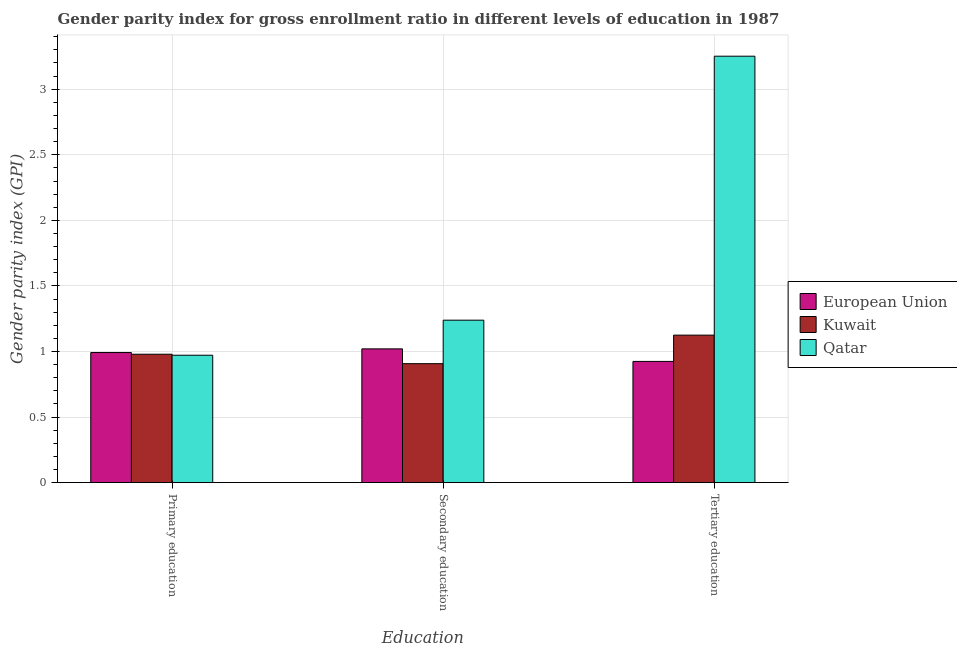Are the number of bars per tick equal to the number of legend labels?
Offer a terse response. Yes. Are the number of bars on each tick of the X-axis equal?
Your answer should be very brief. Yes. What is the label of the 1st group of bars from the left?
Your answer should be very brief. Primary education. What is the gender parity index in secondary education in Kuwait?
Your answer should be very brief. 0.91. Across all countries, what is the maximum gender parity index in tertiary education?
Provide a succinct answer. 3.25. Across all countries, what is the minimum gender parity index in primary education?
Provide a short and direct response. 0.97. In which country was the gender parity index in secondary education maximum?
Make the answer very short. Qatar. What is the total gender parity index in secondary education in the graph?
Keep it short and to the point. 3.17. What is the difference between the gender parity index in primary education in Qatar and that in Kuwait?
Offer a very short reply. -0.01. What is the difference between the gender parity index in tertiary education in Qatar and the gender parity index in primary education in Kuwait?
Keep it short and to the point. 2.27. What is the average gender parity index in tertiary education per country?
Provide a succinct answer. 1.77. What is the difference between the gender parity index in primary education and gender parity index in tertiary education in European Union?
Your answer should be very brief. 0.07. What is the ratio of the gender parity index in primary education in Qatar to that in Kuwait?
Provide a succinct answer. 0.99. Is the gender parity index in primary education in Qatar less than that in European Union?
Provide a short and direct response. Yes. What is the difference between the highest and the second highest gender parity index in tertiary education?
Keep it short and to the point. 2.13. What is the difference between the highest and the lowest gender parity index in secondary education?
Your answer should be very brief. 0.33. In how many countries, is the gender parity index in tertiary education greater than the average gender parity index in tertiary education taken over all countries?
Provide a short and direct response. 1. What does the 3rd bar from the left in Primary education represents?
Your answer should be very brief. Qatar. What does the 2nd bar from the right in Tertiary education represents?
Provide a succinct answer. Kuwait. Is it the case that in every country, the sum of the gender parity index in primary education and gender parity index in secondary education is greater than the gender parity index in tertiary education?
Make the answer very short. No. How many bars are there?
Your answer should be very brief. 9. How many countries are there in the graph?
Give a very brief answer. 3. Are the values on the major ticks of Y-axis written in scientific E-notation?
Offer a terse response. No. Does the graph contain grids?
Your response must be concise. Yes. Where does the legend appear in the graph?
Give a very brief answer. Center right. What is the title of the graph?
Your answer should be compact. Gender parity index for gross enrollment ratio in different levels of education in 1987. Does "Israel" appear as one of the legend labels in the graph?
Provide a short and direct response. No. What is the label or title of the X-axis?
Give a very brief answer. Education. What is the label or title of the Y-axis?
Your response must be concise. Gender parity index (GPI). What is the Gender parity index (GPI) in European Union in Primary education?
Make the answer very short. 0.99. What is the Gender parity index (GPI) in Kuwait in Primary education?
Give a very brief answer. 0.98. What is the Gender parity index (GPI) in Qatar in Primary education?
Offer a very short reply. 0.97. What is the Gender parity index (GPI) of European Union in Secondary education?
Offer a terse response. 1.02. What is the Gender parity index (GPI) of Kuwait in Secondary education?
Give a very brief answer. 0.91. What is the Gender parity index (GPI) of Qatar in Secondary education?
Give a very brief answer. 1.24. What is the Gender parity index (GPI) of European Union in Tertiary education?
Provide a short and direct response. 0.92. What is the Gender parity index (GPI) of Kuwait in Tertiary education?
Your response must be concise. 1.12. What is the Gender parity index (GPI) of Qatar in Tertiary education?
Your answer should be compact. 3.25. Across all Education, what is the maximum Gender parity index (GPI) of European Union?
Your answer should be compact. 1.02. Across all Education, what is the maximum Gender parity index (GPI) of Kuwait?
Offer a very short reply. 1.12. Across all Education, what is the maximum Gender parity index (GPI) of Qatar?
Ensure brevity in your answer.  3.25. Across all Education, what is the minimum Gender parity index (GPI) of European Union?
Your response must be concise. 0.92. Across all Education, what is the minimum Gender parity index (GPI) of Kuwait?
Your answer should be compact. 0.91. Across all Education, what is the minimum Gender parity index (GPI) in Qatar?
Your answer should be very brief. 0.97. What is the total Gender parity index (GPI) of European Union in the graph?
Give a very brief answer. 2.94. What is the total Gender parity index (GPI) of Kuwait in the graph?
Provide a succinct answer. 3.01. What is the total Gender parity index (GPI) in Qatar in the graph?
Make the answer very short. 5.46. What is the difference between the Gender parity index (GPI) in European Union in Primary education and that in Secondary education?
Your response must be concise. -0.03. What is the difference between the Gender parity index (GPI) in Kuwait in Primary education and that in Secondary education?
Offer a very short reply. 0.07. What is the difference between the Gender parity index (GPI) of Qatar in Primary education and that in Secondary education?
Offer a terse response. -0.27. What is the difference between the Gender parity index (GPI) of European Union in Primary education and that in Tertiary education?
Your response must be concise. 0.07. What is the difference between the Gender parity index (GPI) of Kuwait in Primary education and that in Tertiary education?
Provide a short and direct response. -0.15. What is the difference between the Gender parity index (GPI) in Qatar in Primary education and that in Tertiary education?
Your response must be concise. -2.28. What is the difference between the Gender parity index (GPI) of European Union in Secondary education and that in Tertiary education?
Make the answer very short. 0.1. What is the difference between the Gender parity index (GPI) of Kuwait in Secondary education and that in Tertiary education?
Give a very brief answer. -0.22. What is the difference between the Gender parity index (GPI) in Qatar in Secondary education and that in Tertiary education?
Keep it short and to the point. -2.01. What is the difference between the Gender parity index (GPI) in European Union in Primary education and the Gender parity index (GPI) in Kuwait in Secondary education?
Provide a short and direct response. 0.08. What is the difference between the Gender parity index (GPI) in European Union in Primary education and the Gender parity index (GPI) in Qatar in Secondary education?
Your answer should be compact. -0.25. What is the difference between the Gender parity index (GPI) in Kuwait in Primary education and the Gender parity index (GPI) in Qatar in Secondary education?
Provide a succinct answer. -0.26. What is the difference between the Gender parity index (GPI) of European Union in Primary education and the Gender parity index (GPI) of Kuwait in Tertiary education?
Offer a very short reply. -0.13. What is the difference between the Gender parity index (GPI) in European Union in Primary education and the Gender parity index (GPI) in Qatar in Tertiary education?
Provide a succinct answer. -2.26. What is the difference between the Gender parity index (GPI) of Kuwait in Primary education and the Gender parity index (GPI) of Qatar in Tertiary education?
Offer a very short reply. -2.27. What is the difference between the Gender parity index (GPI) in European Union in Secondary education and the Gender parity index (GPI) in Kuwait in Tertiary education?
Your response must be concise. -0.1. What is the difference between the Gender parity index (GPI) in European Union in Secondary education and the Gender parity index (GPI) in Qatar in Tertiary education?
Your answer should be very brief. -2.23. What is the difference between the Gender parity index (GPI) in Kuwait in Secondary education and the Gender parity index (GPI) in Qatar in Tertiary education?
Offer a terse response. -2.34. What is the average Gender parity index (GPI) in European Union per Education?
Ensure brevity in your answer.  0.98. What is the average Gender parity index (GPI) in Qatar per Education?
Your answer should be compact. 1.82. What is the difference between the Gender parity index (GPI) of European Union and Gender parity index (GPI) of Kuwait in Primary education?
Provide a short and direct response. 0.01. What is the difference between the Gender parity index (GPI) of European Union and Gender parity index (GPI) of Qatar in Primary education?
Offer a very short reply. 0.02. What is the difference between the Gender parity index (GPI) of Kuwait and Gender parity index (GPI) of Qatar in Primary education?
Your answer should be very brief. 0.01. What is the difference between the Gender parity index (GPI) in European Union and Gender parity index (GPI) in Kuwait in Secondary education?
Your answer should be very brief. 0.11. What is the difference between the Gender parity index (GPI) of European Union and Gender parity index (GPI) of Qatar in Secondary education?
Ensure brevity in your answer.  -0.22. What is the difference between the Gender parity index (GPI) of Kuwait and Gender parity index (GPI) of Qatar in Secondary education?
Keep it short and to the point. -0.33. What is the difference between the Gender parity index (GPI) in European Union and Gender parity index (GPI) in Kuwait in Tertiary education?
Your answer should be compact. -0.2. What is the difference between the Gender parity index (GPI) in European Union and Gender parity index (GPI) in Qatar in Tertiary education?
Your answer should be compact. -2.33. What is the difference between the Gender parity index (GPI) of Kuwait and Gender parity index (GPI) of Qatar in Tertiary education?
Your answer should be very brief. -2.13. What is the ratio of the Gender parity index (GPI) in European Union in Primary education to that in Secondary education?
Offer a very short reply. 0.97. What is the ratio of the Gender parity index (GPI) in Kuwait in Primary education to that in Secondary education?
Offer a very short reply. 1.08. What is the ratio of the Gender parity index (GPI) of Qatar in Primary education to that in Secondary education?
Make the answer very short. 0.78. What is the ratio of the Gender parity index (GPI) of European Union in Primary education to that in Tertiary education?
Make the answer very short. 1.07. What is the ratio of the Gender parity index (GPI) of Kuwait in Primary education to that in Tertiary education?
Your answer should be very brief. 0.87. What is the ratio of the Gender parity index (GPI) of Qatar in Primary education to that in Tertiary education?
Give a very brief answer. 0.3. What is the ratio of the Gender parity index (GPI) in European Union in Secondary education to that in Tertiary education?
Make the answer very short. 1.1. What is the ratio of the Gender parity index (GPI) in Kuwait in Secondary education to that in Tertiary education?
Give a very brief answer. 0.81. What is the ratio of the Gender parity index (GPI) of Qatar in Secondary education to that in Tertiary education?
Your response must be concise. 0.38. What is the difference between the highest and the second highest Gender parity index (GPI) in European Union?
Your answer should be compact. 0.03. What is the difference between the highest and the second highest Gender parity index (GPI) of Kuwait?
Your answer should be very brief. 0.15. What is the difference between the highest and the second highest Gender parity index (GPI) of Qatar?
Provide a short and direct response. 2.01. What is the difference between the highest and the lowest Gender parity index (GPI) of European Union?
Your answer should be compact. 0.1. What is the difference between the highest and the lowest Gender parity index (GPI) in Kuwait?
Provide a short and direct response. 0.22. What is the difference between the highest and the lowest Gender parity index (GPI) of Qatar?
Give a very brief answer. 2.28. 